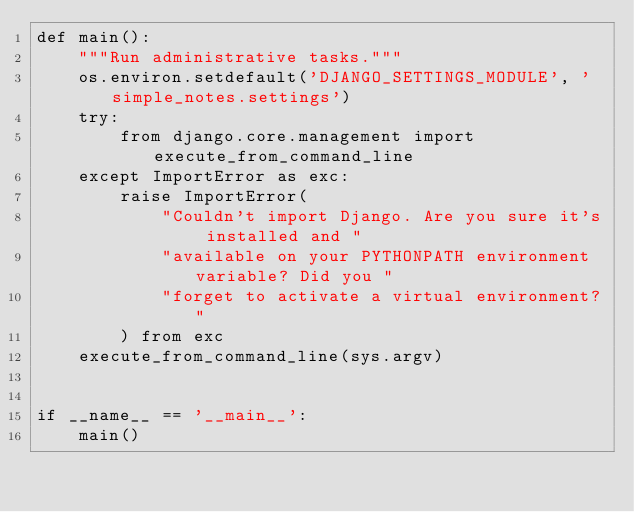<code> <loc_0><loc_0><loc_500><loc_500><_Python_>def main():
    """Run administrative tasks."""
    os.environ.setdefault('DJANGO_SETTINGS_MODULE', 'simple_notes.settings')
    try:
        from django.core.management import execute_from_command_line
    except ImportError as exc:
        raise ImportError(
            "Couldn't import Django. Are you sure it's installed and "
            "available on your PYTHONPATH environment variable? Did you "
            "forget to activate a virtual environment?"
        ) from exc
    execute_from_command_line(sys.argv)


if __name__ == '__main__':
    main()
</code> 